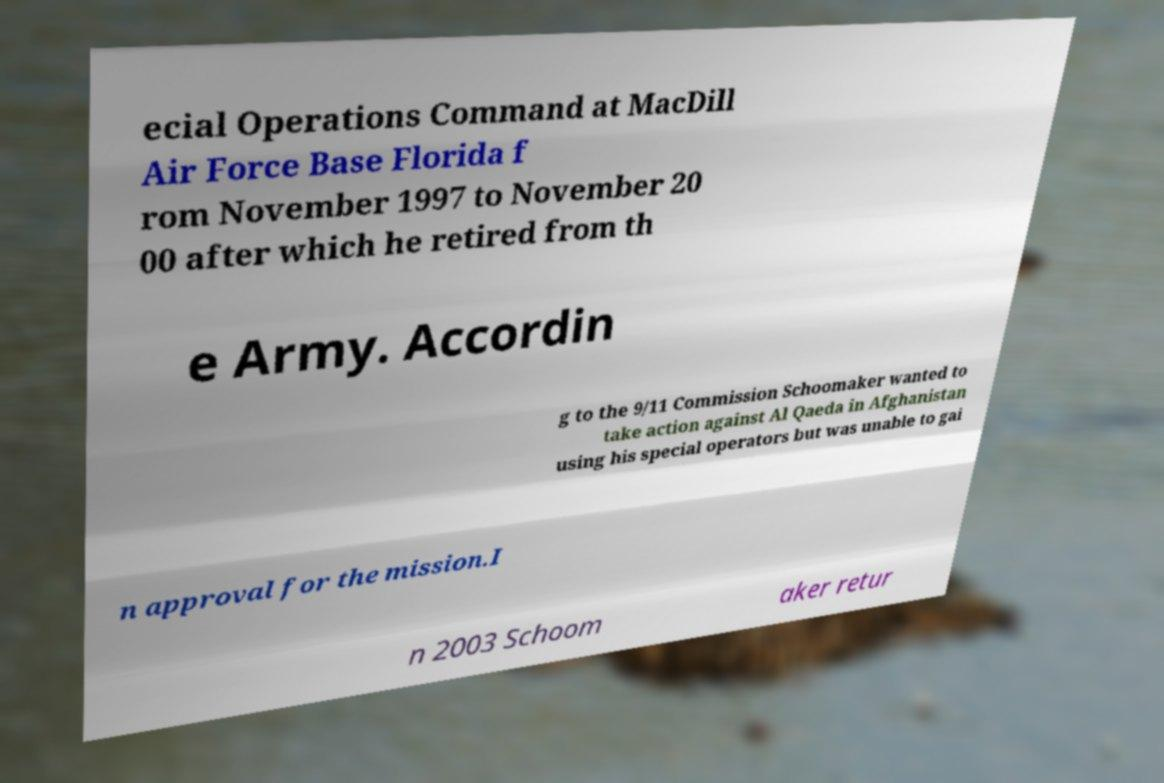Please identify and transcribe the text found in this image. ecial Operations Command at MacDill Air Force Base Florida f rom November 1997 to November 20 00 after which he retired from th e Army. Accordin g to the 9/11 Commission Schoomaker wanted to take action against Al Qaeda in Afghanistan using his special operators but was unable to gai n approval for the mission.I n 2003 Schoom aker retur 